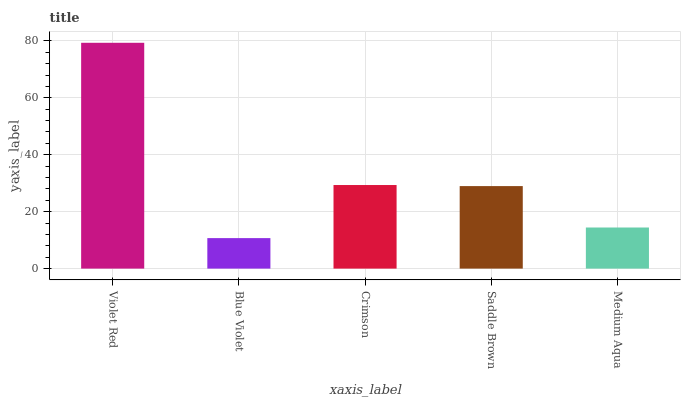Is Crimson the minimum?
Answer yes or no. No. Is Crimson the maximum?
Answer yes or no. No. Is Crimson greater than Blue Violet?
Answer yes or no. Yes. Is Blue Violet less than Crimson?
Answer yes or no. Yes. Is Blue Violet greater than Crimson?
Answer yes or no. No. Is Crimson less than Blue Violet?
Answer yes or no. No. Is Saddle Brown the high median?
Answer yes or no. Yes. Is Saddle Brown the low median?
Answer yes or no. Yes. Is Crimson the high median?
Answer yes or no. No. Is Medium Aqua the low median?
Answer yes or no. No. 